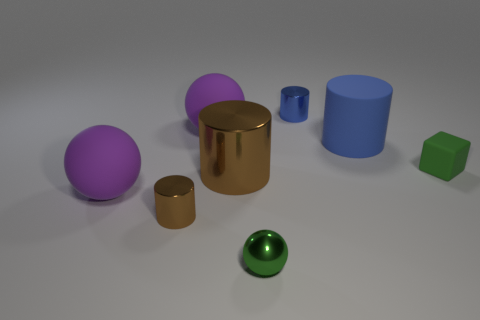Subtract 1 cylinders. How many cylinders are left? 3 Add 2 big blue matte cylinders. How many objects exist? 10 Subtract all spheres. How many objects are left? 5 Subtract all green rubber blocks. Subtract all small matte blocks. How many objects are left? 6 Add 2 purple balls. How many purple balls are left? 4 Add 2 green matte blocks. How many green matte blocks exist? 3 Subtract 0 cyan blocks. How many objects are left? 8 